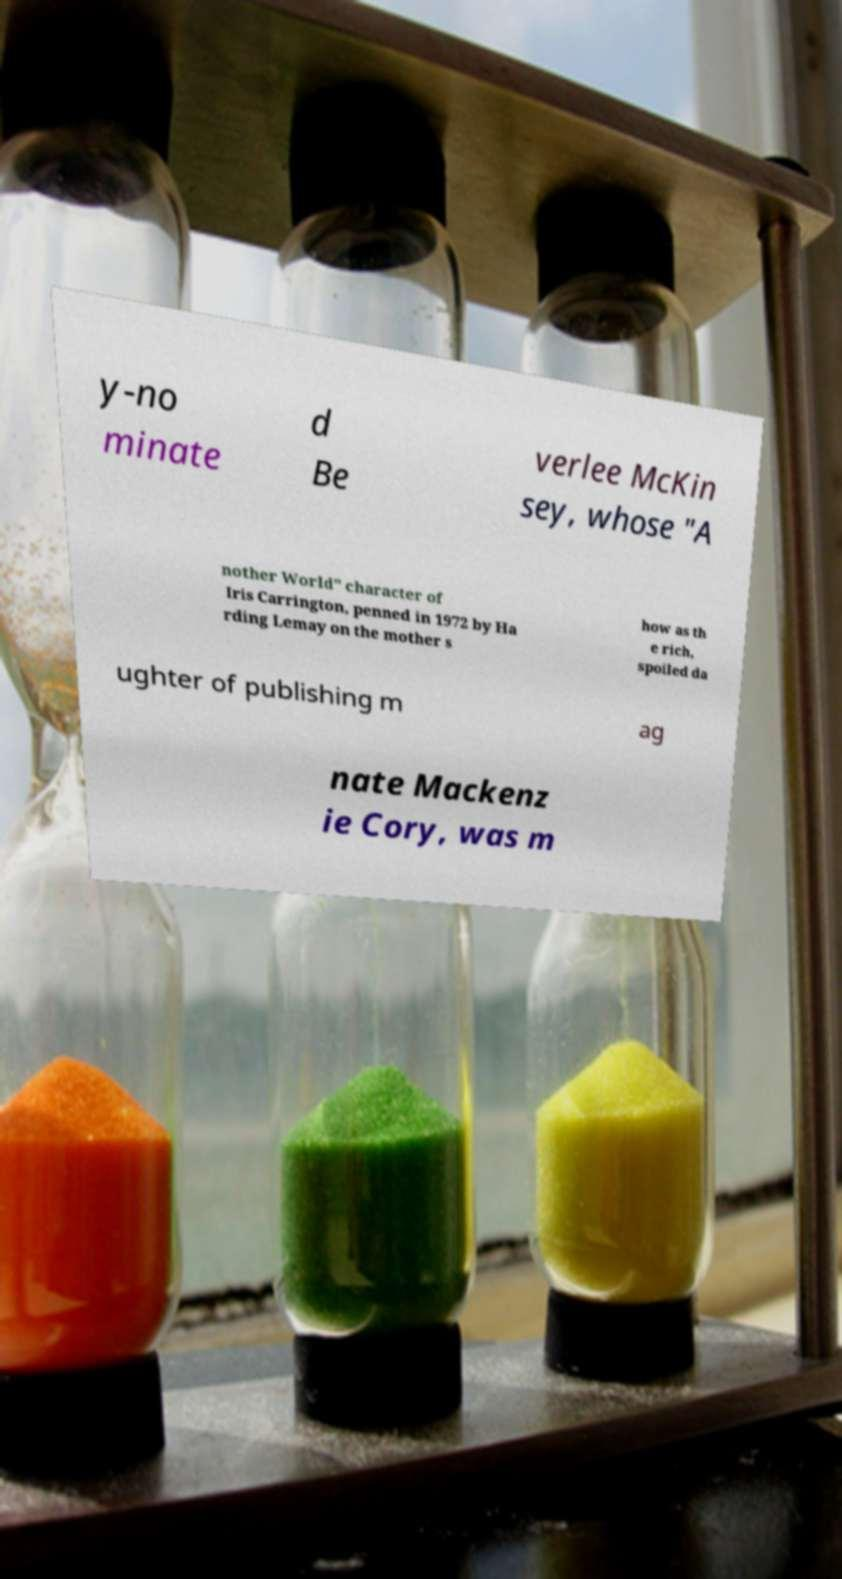There's text embedded in this image that I need extracted. Can you transcribe it verbatim? y-no minate d Be verlee McKin sey, whose "A nother World" character of Iris Carrington, penned in 1972 by Ha rding Lemay on the mother s how as th e rich, spoiled da ughter of publishing m ag nate Mackenz ie Cory, was m 